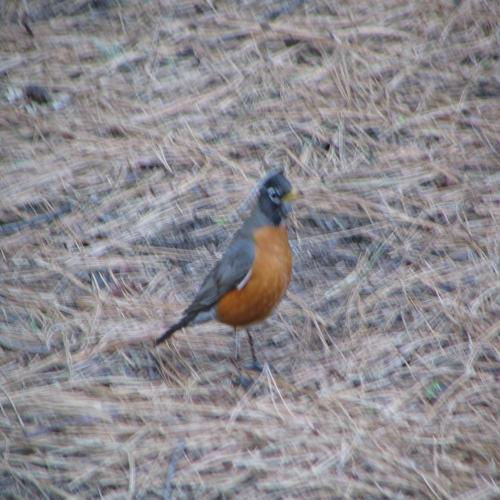What might the bird be doing in this setting? The bird, possibly an American Robin, seems to be foraging. This species is known to feed on earthworms and insects, which they find by hunting through grassy areas. Its alert posture suggests it might be looking or listening for its next meal. Are there any signs of human activity in the area where the bird is found? The image doesn't show any immediate signs of human presence, such as pathways, litter, or structures. However, the trimmed appearance of the grass could indicate that the area is maintained by people, possibly as part of a public outdoor space. 